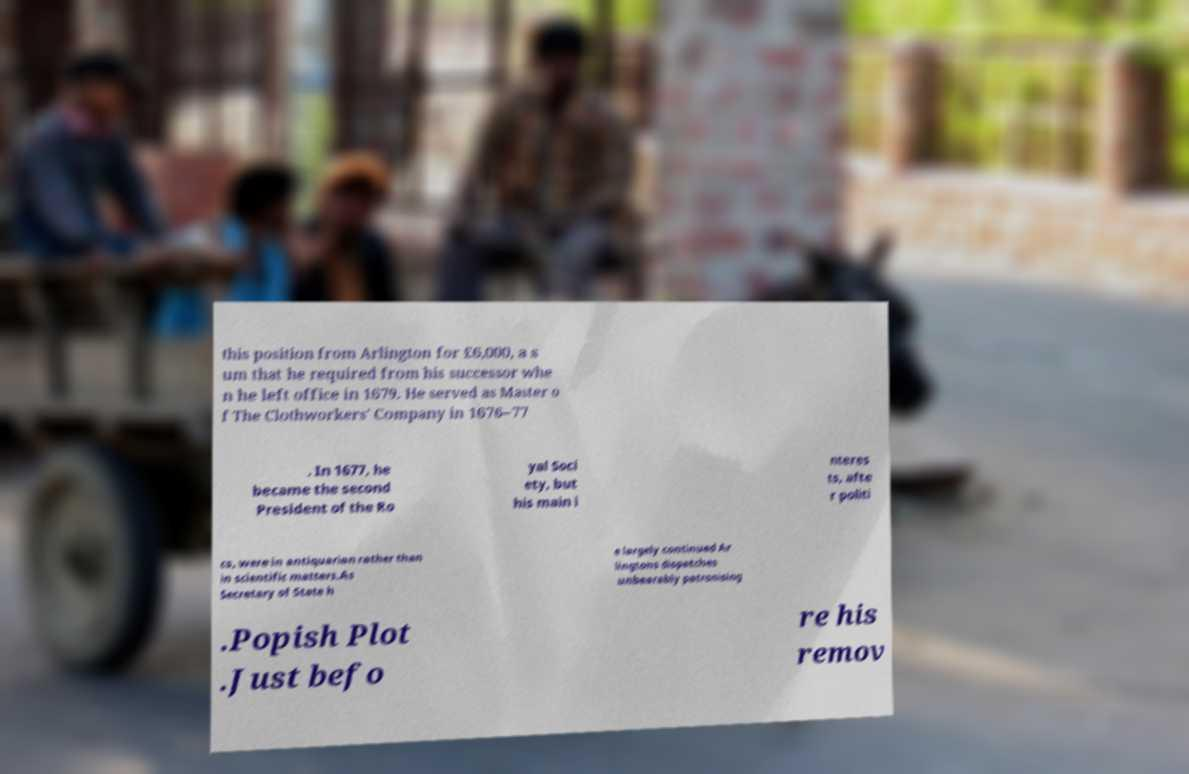Can you accurately transcribe the text from the provided image for me? this position from Arlington for £6,000, a s um that he required from his successor whe n he left office in 1679. He served as Master o f The Clothworkers' Company in 1676–77 . In 1677, he became the second President of the Ro yal Soci ety, but his main i nteres ts, afte r politi cs, were in antiquarian rather than in scientific matters.As Secretary of State h e largely continued Ar lingtons dispatches unbearably patronising .Popish Plot .Just befo re his remov 